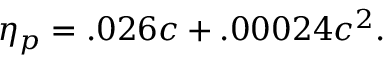Convert formula to latex. <formula><loc_0><loc_0><loc_500><loc_500>\eta _ { p } = . 0 2 6 c + . 0 0 0 2 4 c ^ { 2 } .</formula> 